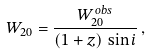<formula> <loc_0><loc_0><loc_500><loc_500>W _ { 2 0 } = \frac { W _ { 2 0 } ^ { o b s } } { ( 1 + z ) \, \sin i } \, ,</formula> 